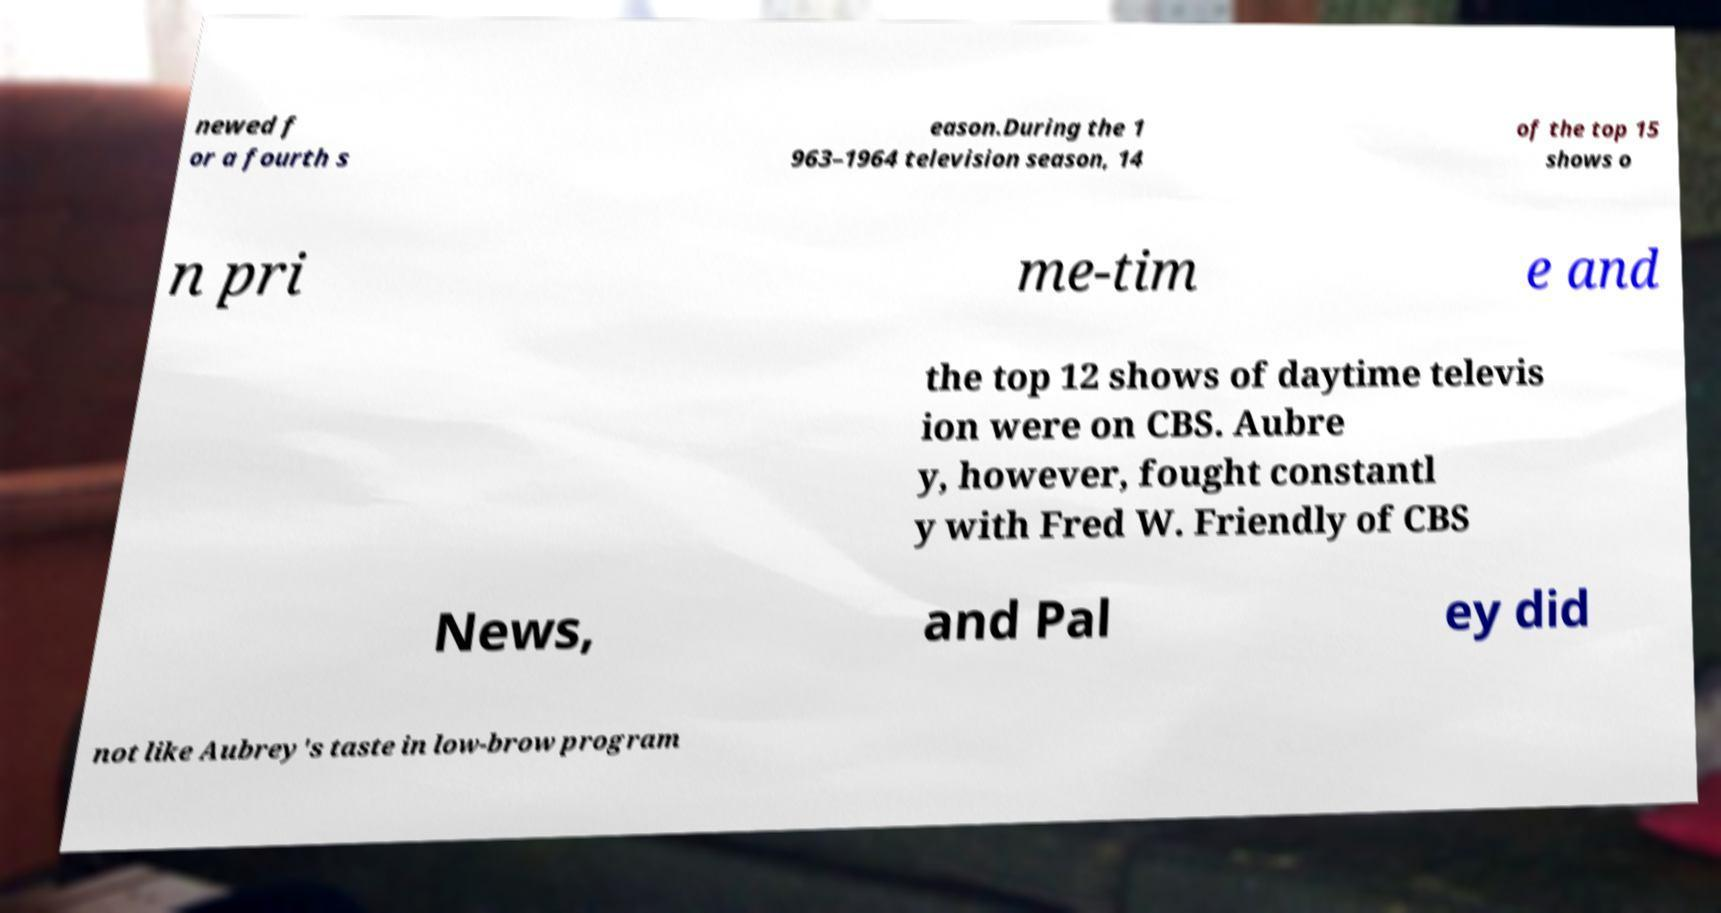Can you accurately transcribe the text from the provided image for me? newed f or a fourth s eason.During the 1 963–1964 television season, 14 of the top 15 shows o n pri me-tim e and the top 12 shows of daytime televis ion were on CBS. Aubre y, however, fought constantl y with Fred W. Friendly of CBS News, and Pal ey did not like Aubrey's taste in low-brow program 